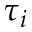<formula> <loc_0><loc_0><loc_500><loc_500>\tau _ { i }</formula> 